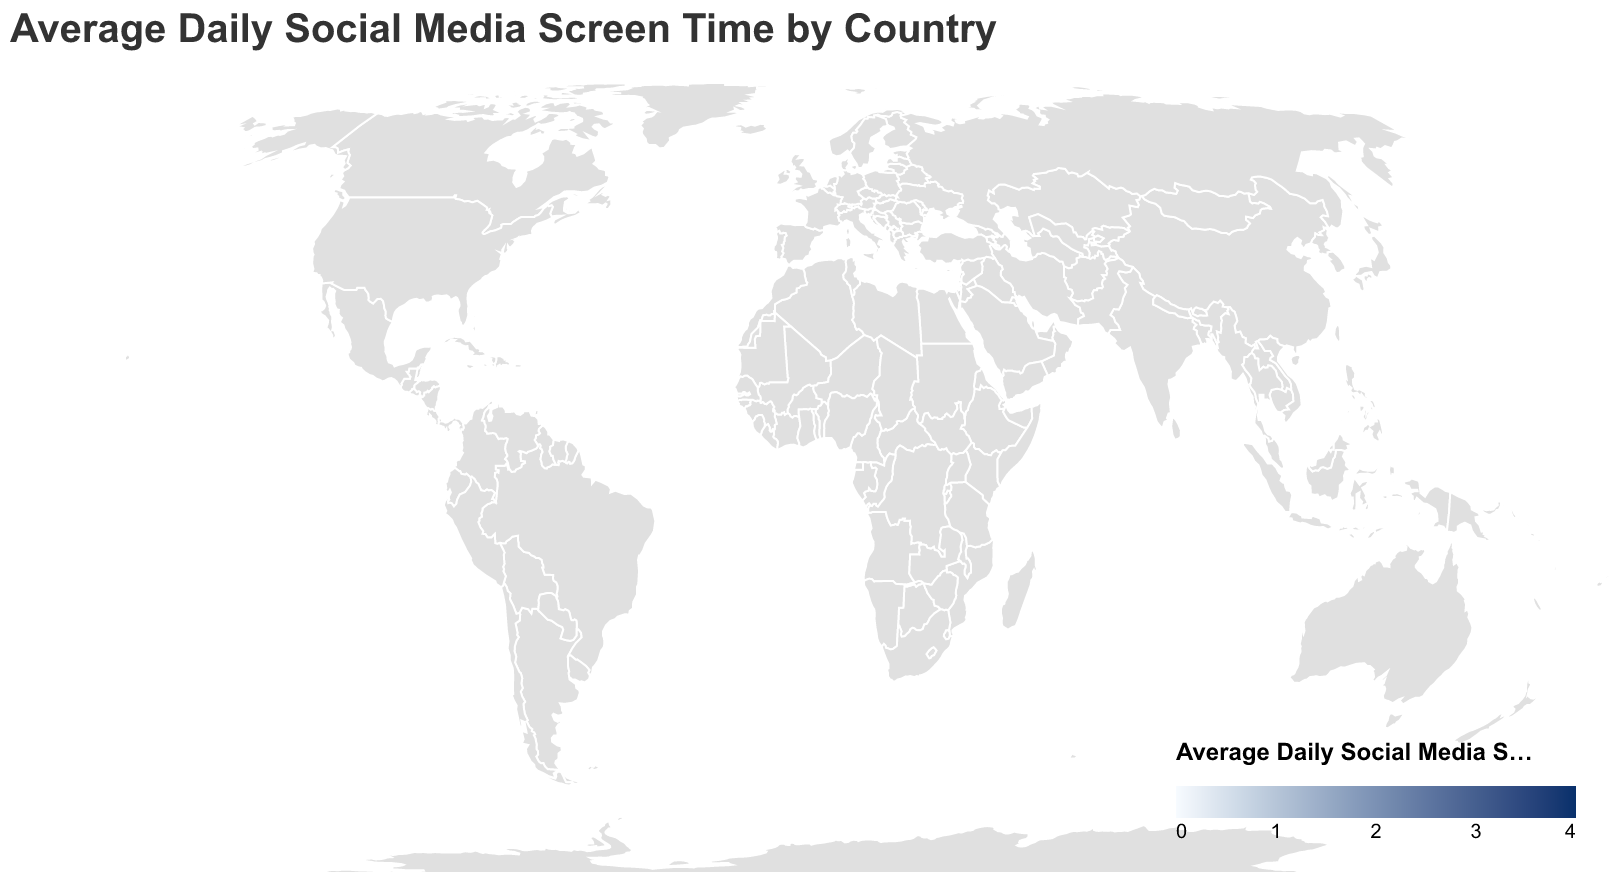What is the title of the figure? The title is typically located at the top of the figure. It provides a succinct description of what the figure represents.
Answer: Average Daily Social Media Screen Time by Country Which country has the highest average daily social media screen time? By examining the color gradient on the map, we can see which country has the darkest shade, indicating the highest screen time. Here, Brazil has the darkest shade.
Answer: Brazil What is the average daily social media screen time in Japan? By hovering over Japan on the map or checking its color in the legend, we can see the exact screen time displayed. According to the data, Japan's screen time is 0.8 hours.
Answer: 0.8 hours How many countries have an average daily social media screen time of 3 hours or more? We need to identify countries with the darkest shades on the map or those that the legend indicates are at or above the 3-hour mark. The countries are Brazil, Nigeria, Mexico, and Indonesia which add up to 4 countries.
Answer: 4 countries Which country has a lower average daily social media screen time: Germany or Italy? By comparing Germany and Italy on the map or referencing the legend, Germany has a screen time of 1.5 hours, and Italy has 1.7 hours. Thus, Germany has a lower screen time.
Answer: Germany What is the average daily social media screen time for countries in Europe? To determine this, we need to sum the average daily social media screen times of European countries (United Kingdom, Germany, France, Russia, Spain, Italy, Netherlands, Sweden) and then divide by the number of these countries. (1.9 + 1.5 + 1.6 + 2.4 + 1.8 + 1.7 + 1.4 + 1.3) / 8 = 1.7 hours.
Answer: 1.7 hours Which region appears to have a higher average daily social media screen time, South America or Europe? By comparing the colors or shading for South American (here, Brazil and Mexico) and European countries, South America generally has darker shades, indicating higher screen time compared to Europe.
Answer: South America What is the range of average daily social media screen time values depicted in this figure? To find the range, we subtract the smallest value from the largest value. The smallest value is 0.8 hours (Japan), and the largest is 3.5 hours (Brazil). Therefore, the range is 3.5 - 0.8 = 2.7 hours.
Answer: 2.7 hours 